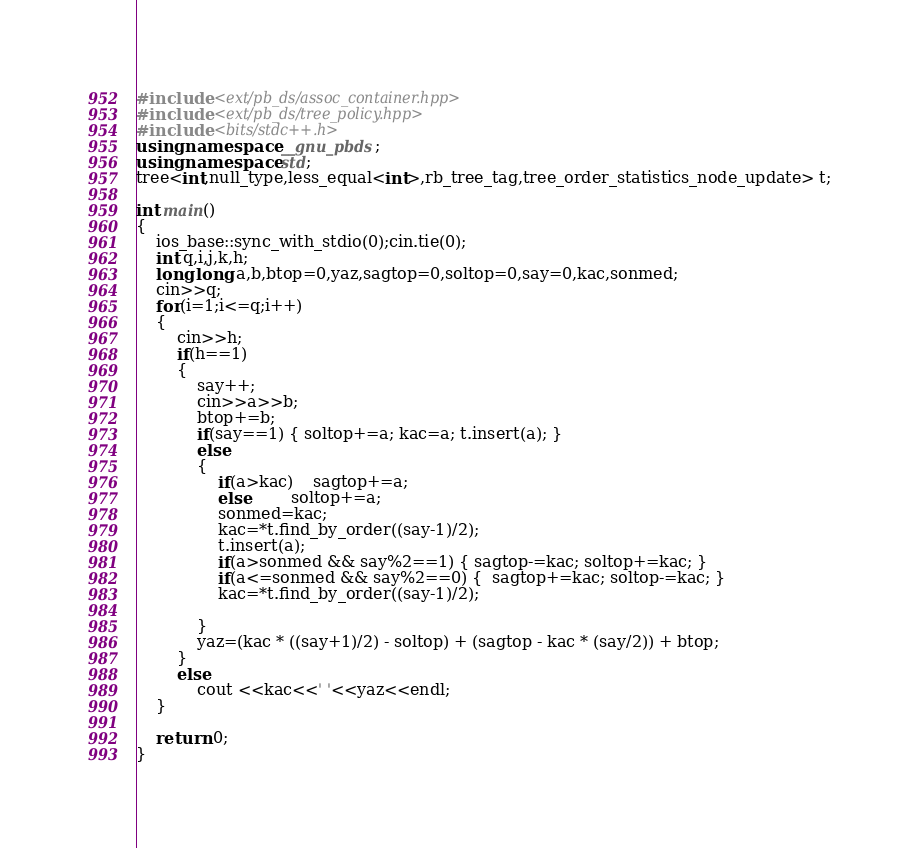<code> <loc_0><loc_0><loc_500><loc_500><_C++_>#include <ext/pb_ds/assoc_container.hpp>
#include <ext/pb_ds/tree_policy.hpp>
#include <bits/stdc++.h>
using namespace __gnu_pbds;
using namespace std;
tree<int,null_type,less_equal<int>,rb_tree_tag,tree_order_statistics_node_update> t;
     
int main()
{
	ios_base::sync_with_stdio(0);cin.tie(0);
	int q,i,j,k,h;
	long long a,b,btop=0,yaz,sagtop=0,soltop=0,say=0,kac,sonmed;
	cin>>q;
	for(i=1;i<=q;i++)
	{
		cin>>h;
		if(h==1)
		{
			say++;
			cin>>a>>b;
			btop+=b;
			if(say==1) { soltop+=a; kac=a; t.insert(a); }
			else
			{
				if(a>kac)	sagtop+=a;
				else		soltop+=a;
				sonmed=kac;
				kac=*t.find_by_order((say-1)/2);
				t.insert(a);	
				if(a>sonmed && say%2==1) { sagtop-=kac; soltop+=kac; }
				if(a<=sonmed && say%2==0) {  sagtop+=kac; soltop-=kac; }
				kac=*t.find_by_order((say-1)/2);
			
			}
			yaz=(kac * ((say+1)/2) - soltop) + (sagtop - kac * (say/2)) + btop;	
		}
		else
			cout <<kac<<' '<<yaz<<endl;
	}

	return 0;
}</code> 